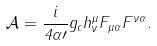<formula> <loc_0><loc_0><loc_500><loc_500>\mathcal { A } = \frac { i } { 4 \alpha \prime } g _ { c } h _ { \nu } ^ { \mu } F _ { \mu \alpha } F ^ { \nu \alpha } .</formula> 